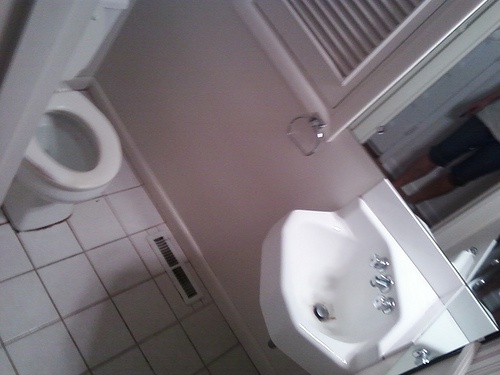Describe the objects in this image and their specific colors. I can see sink in gray, lightgray, and darkgray tones, toilet in gray and darkgray tones, and people in gray and black tones in this image. 